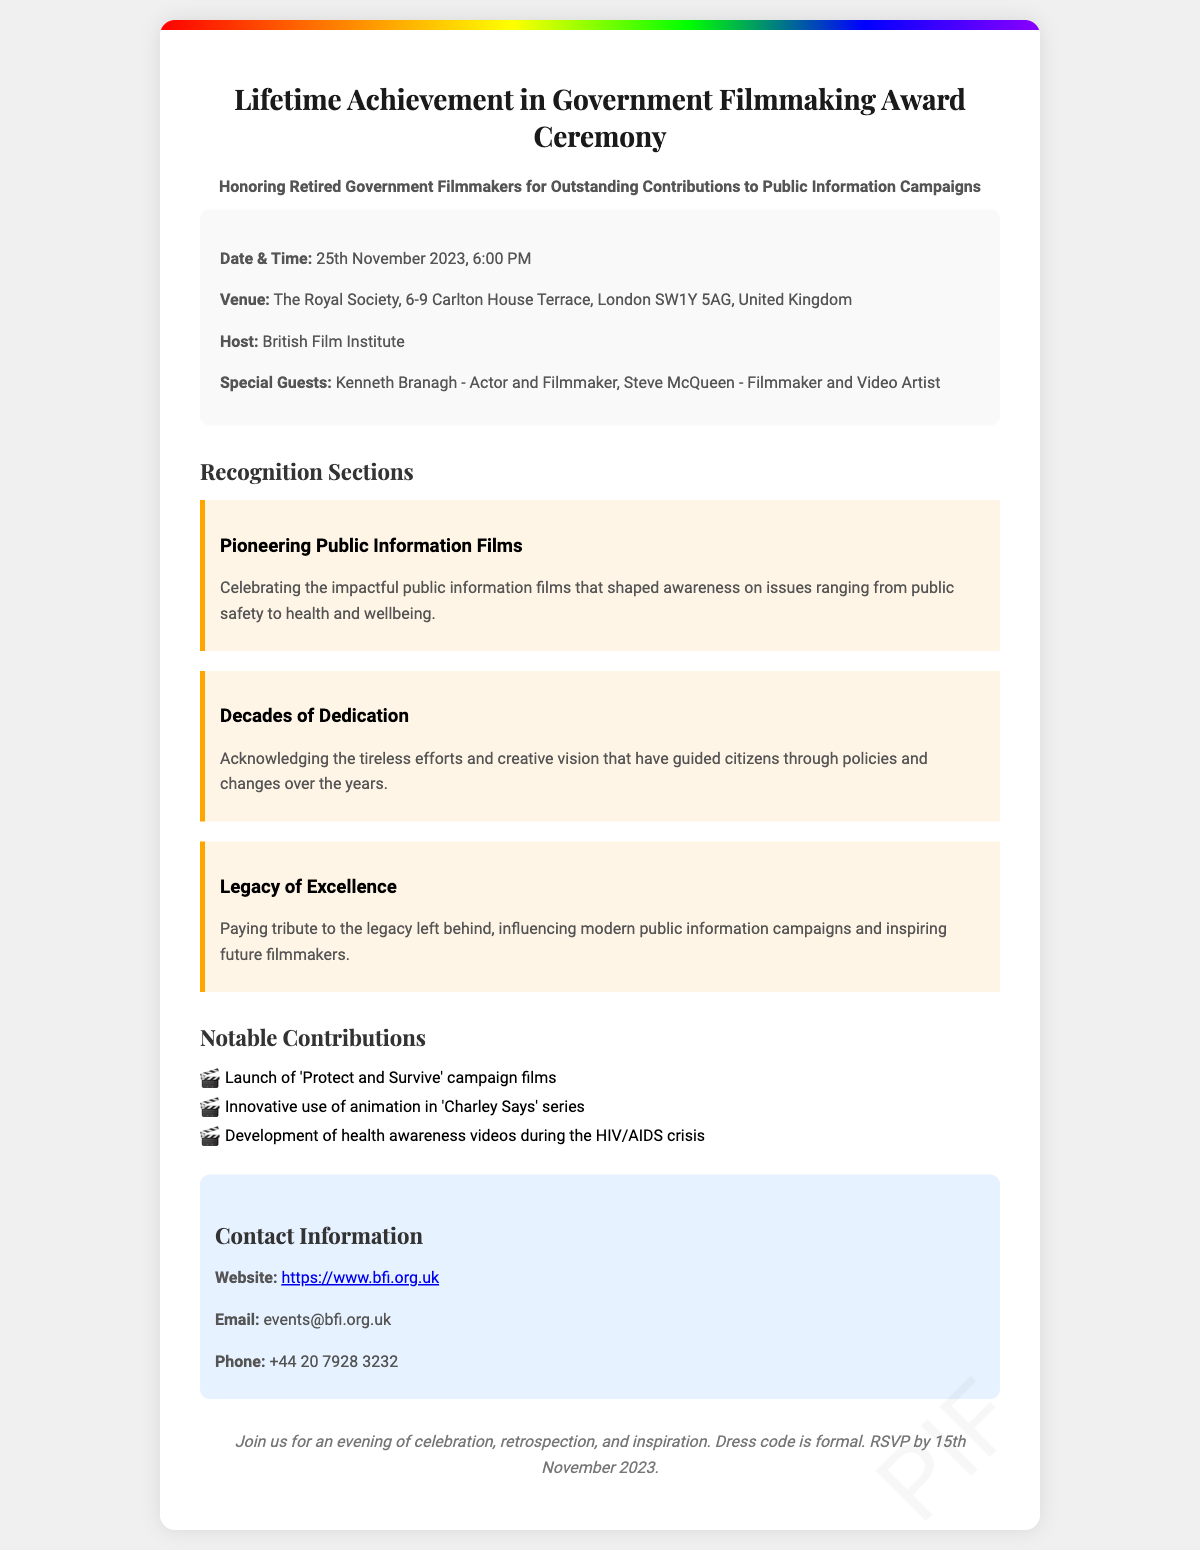What is the date of the ceremony? The document specifies the date when the ceremony will take place, which is 25th November 2023.
Answer: 25th November 2023 Who is hosting the event? According to the document, the British Film Institute is mentioned as the host of the ceremony.
Answer: British Film Institute Where is the venue located? The ticket provides the venue details, specifying The Royal Society as the location along with its address.
Answer: The Royal Society, 6-9 Carlton House Terrace, London SW1Y 5AG, United Kingdom Name a special guest attending. The document lists special guests, including notable individuals such as Kenneth Branagh.
Answer: Kenneth Branagh What is a notable contribution mentioned? The document includes a section detailing notable contributions, one of which is the launch of the 'Protect and Survive' campaign films.
Answer: Launch of 'Protect and Survive' campaign films What is the RSVP deadline? The document states that the RSVP should be completed by 15th November 2023.
Answer: 15th November 2023 What is the dress code for the event? The ticket mentions specific instructions regarding attire for attendees, indicating that the dress code is formal.
Answer: Formal What is one section of recognition described? The ticket outlines various sections of recognition, one of which focuses on Pioneering Public Information Films.
Answer: Pioneering Public Information Films What type of films does the ceremony celebrate? The document emphasizes the subject matter of the celebration, showcasing outstanding contributions to public information campaigns.
Answer: Public information campaigns 